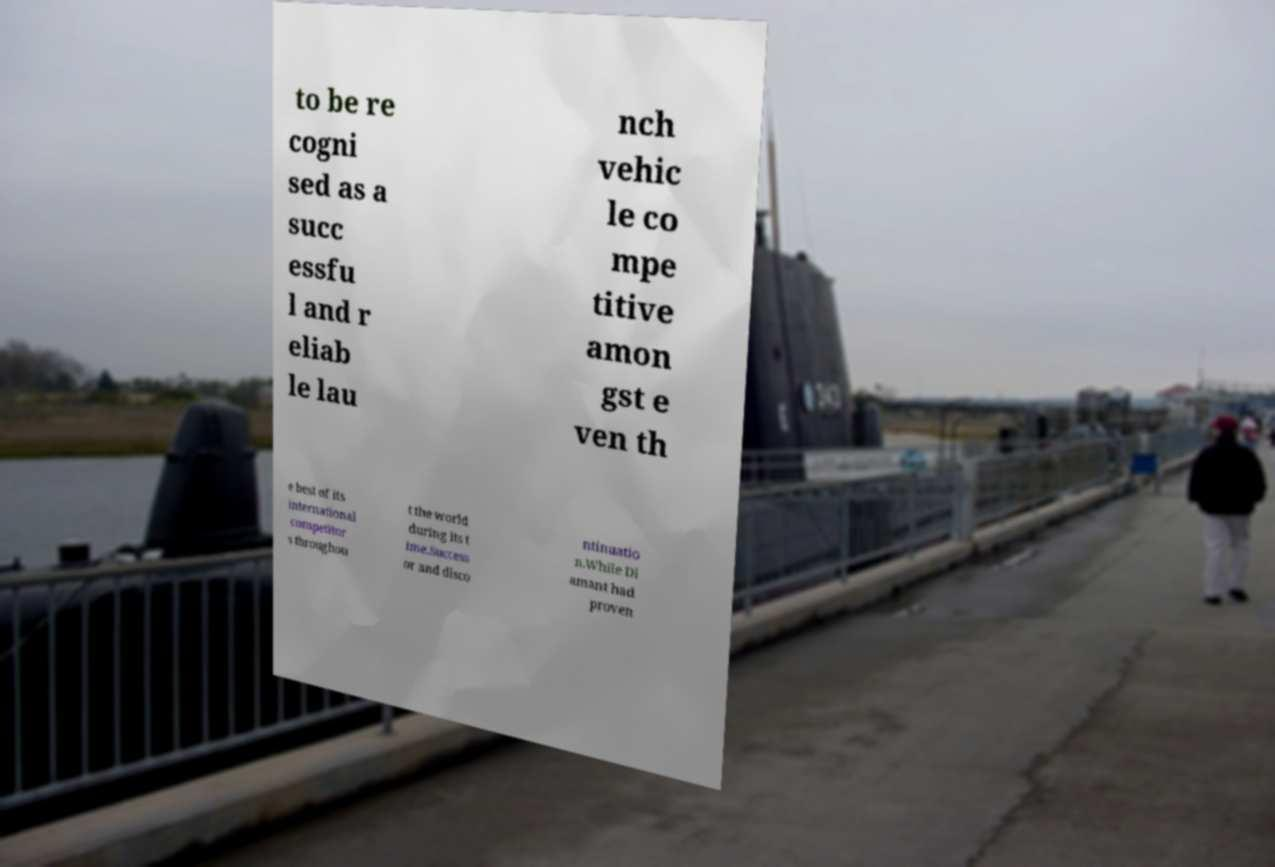Can you accurately transcribe the text from the provided image for me? to be re cogni sed as a succ essfu l and r eliab le lau nch vehic le co mpe titive amon gst e ven th e best of its international competitor s throughou t the world during its t ime.Success or and disco ntinuatio n.While Di amant had proven 